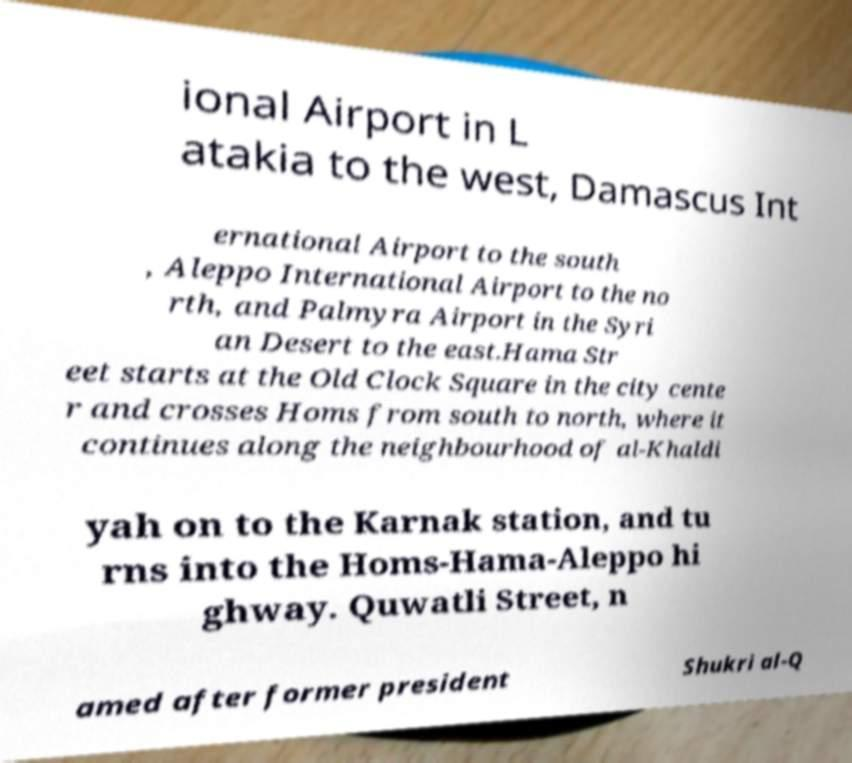Please read and relay the text visible in this image. What does it say? ional Airport in L atakia to the west, Damascus Int ernational Airport to the south , Aleppo International Airport to the no rth, and Palmyra Airport in the Syri an Desert to the east.Hama Str eet starts at the Old Clock Square in the city cente r and crosses Homs from south to north, where it continues along the neighbourhood of al-Khaldi yah on to the Karnak station, and tu rns into the Homs-Hama-Aleppo hi ghway. Quwatli Street, n amed after former president Shukri al-Q 